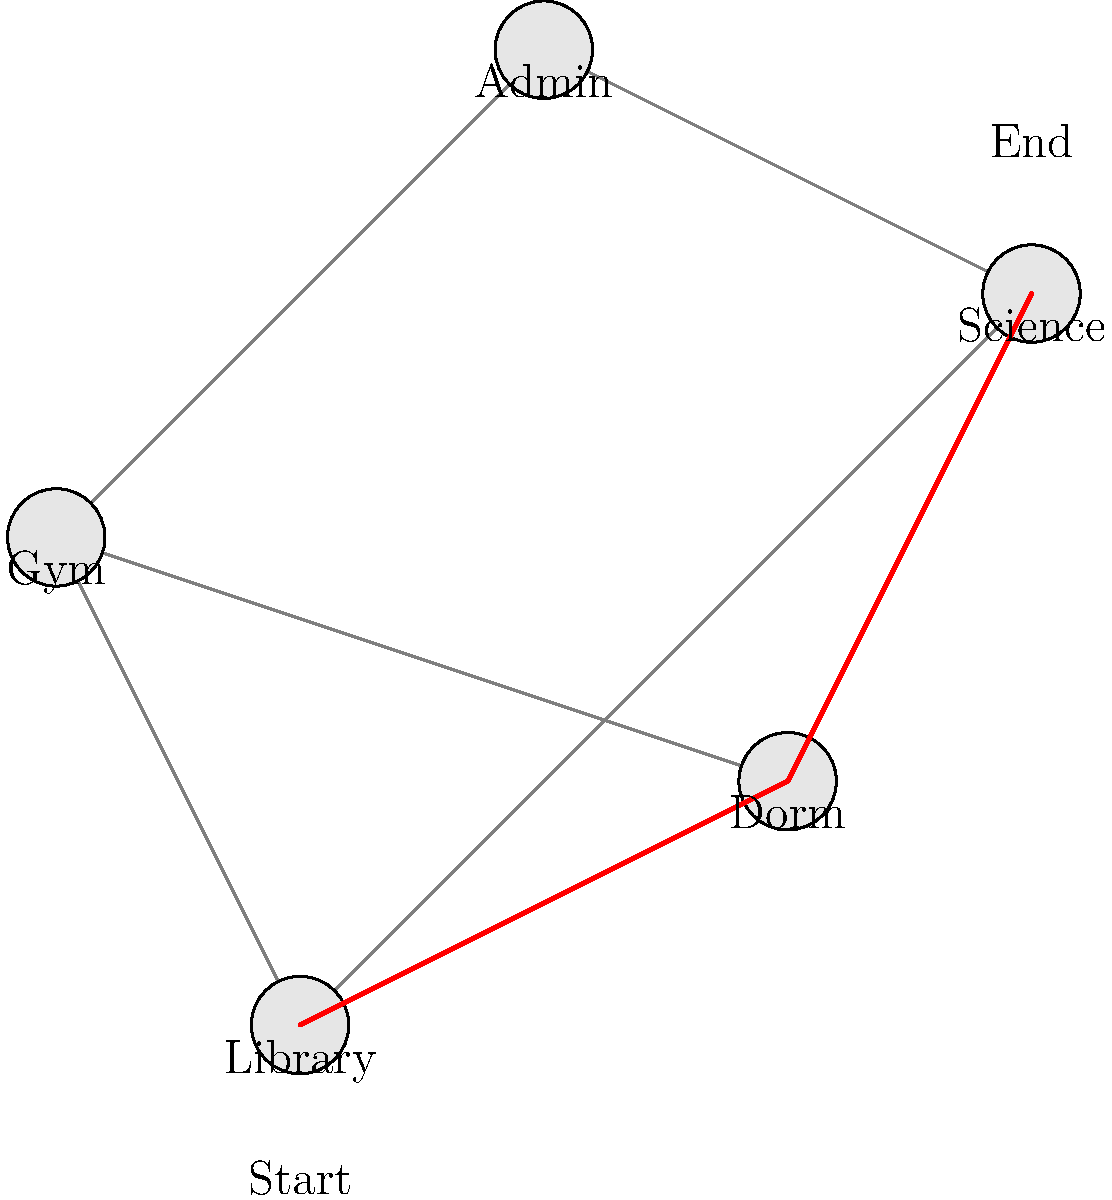As a parent volunteer organizing college information sessions, you're tasked with guiding students from the Library to the Science building on the campus map. Which path should you recommend for the most direct route? To determine the most direct route from the Library to the Science building, let's analyze the map step-by-step:

1. Identify the starting point (Library) and the destination (Science building).
2. Observe all possible paths connecting these two points.
3. Compare the lengths of these paths:
   a. Library -> Dorm -> Science
   b. Library -> Gym -> Admin -> Science
   c. Library -> Science (direct path)

4. The direct path (Library -> Science) is clearly the shortest and most direct route.
5. This path is highlighted in red on the map.
6. It passes through only one intermediate point (Dorm) before reaching the Science building.

By recommending this route, you ensure students take the most efficient path between the two buildings, saving time and reducing the chance of getting lost on campus.
Answer: Library -> Dorm -> Science 